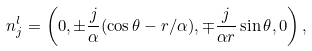Convert formula to latex. <formula><loc_0><loc_0><loc_500><loc_500>n ^ { l } _ { j } = \left ( 0 , \pm \frac { j } { \alpha } ( \cos \theta - r / \alpha ) , \mp \frac { j } { \alpha r } \sin \theta , 0 \right ) ,</formula> 